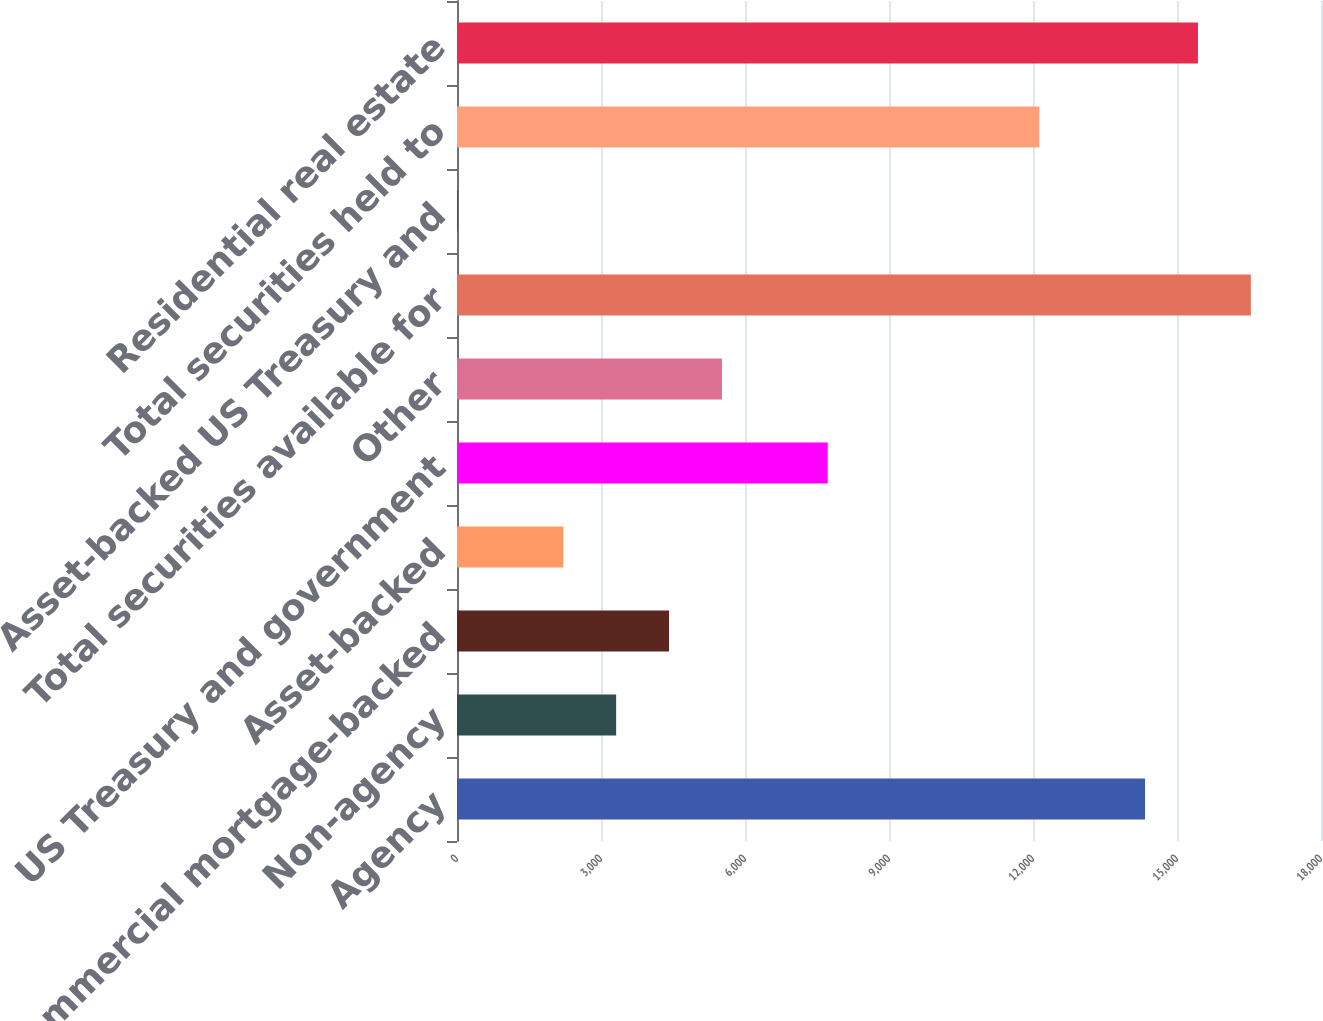Convert chart. <chart><loc_0><loc_0><loc_500><loc_500><bar_chart><fcel>Agency<fcel>Non-agency<fcel>Commercial mortgage-backed<fcel>Asset-backed<fcel>US Treasury and government<fcel>Other<fcel>Total securities available for<fcel>Asset-backed US Treasury and<fcel>Total securities held to<fcel>Residential real estate<nl><fcel>14334.7<fcel>3315.7<fcel>4417.6<fcel>2213.8<fcel>7723.3<fcel>5519.5<fcel>16538.5<fcel>10<fcel>12130.9<fcel>15436.6<nl></chart> 